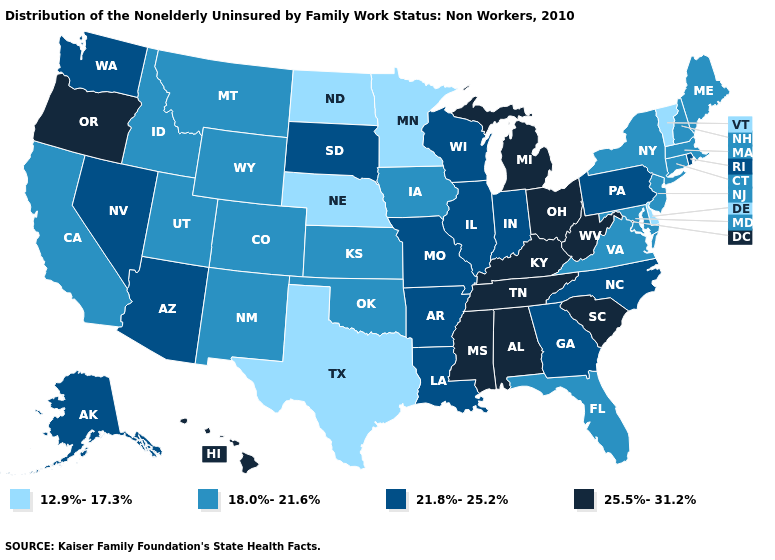Among the states that border Pennsylvania , which have the lowest value?
Answer briefly. Delaware. What is the value of Maine?
Be succinct. 18.0%-21.6%. What is the value of Maryland?
Concise answer only. 18.0%-21.6%. What is the value of Arizona?
Quick response, please. 21.8%-25.2%. Name the states that have a value in the range 25.5%-31.2%?
Answer briefly. Alabama, Hawaii, Kentucky, Michigan, Mississippi, Ohio, Oregon, South Carolina, Tennessee, West Virginia. Does Massachusetts have a higher value than Vermont?
Concise answer only. Yes. Among the states that border Missouri , which have the highest value?
Short answer required. Kentucky, Tennessee. Name the states that have a value in the range 18.0%-21.6%?
Concise answer only. California, Colorado, Connecticut, Florida, Idaho, Iowa, Kansas, Maine, Maryland, Massachusetts, Montana, New Hampshire, New Jersey, New Mexico, New York, Oklahoma, Utah, Virginia, Wyoming. What is the value of Michigan?
Give a very brief answer. 25.5%-31.2%. Which states hav the highest value in the South?
Answer briefly. Alabama, Kentucky, Mississippi, South Carolina, Tennessee, West Virginia. Name the states that have a value in the range 21.8%-25.2%?
Concise answer only. Alaska, Arizona, Arkansas, Georgia, Illinois, Indiana, Louisiana, Missouri, Nevada, North Carolina, Pennsylvania, Rhode Island, South Dakota, Washington, Wisconsin. Which states have the highest value in the USA?
Answer briefly. Alabama, Hawaii, Kentucky, Michigan, Mississippi, Ohio, Oregon, South Carolina, Tennessee, West Virginia. What is the highest value in states that border Tennessee?
Write a very short answer. 25.5%-31.2%. Name the states that have a value in the range 18.0%-21.6%?
Short answer required. California, Colorado, Connecticut, Florida, Idaho, Iowa, Kansas, Maine, Maryland, Massachusetts, Montana, New Hampshire, New Jersey, New Mexico, New York, Oklahoma, Utah, Virginia, Wyoming. Which states hav the highest value in the West?
Be succinct. Hawaii, Oregon. 